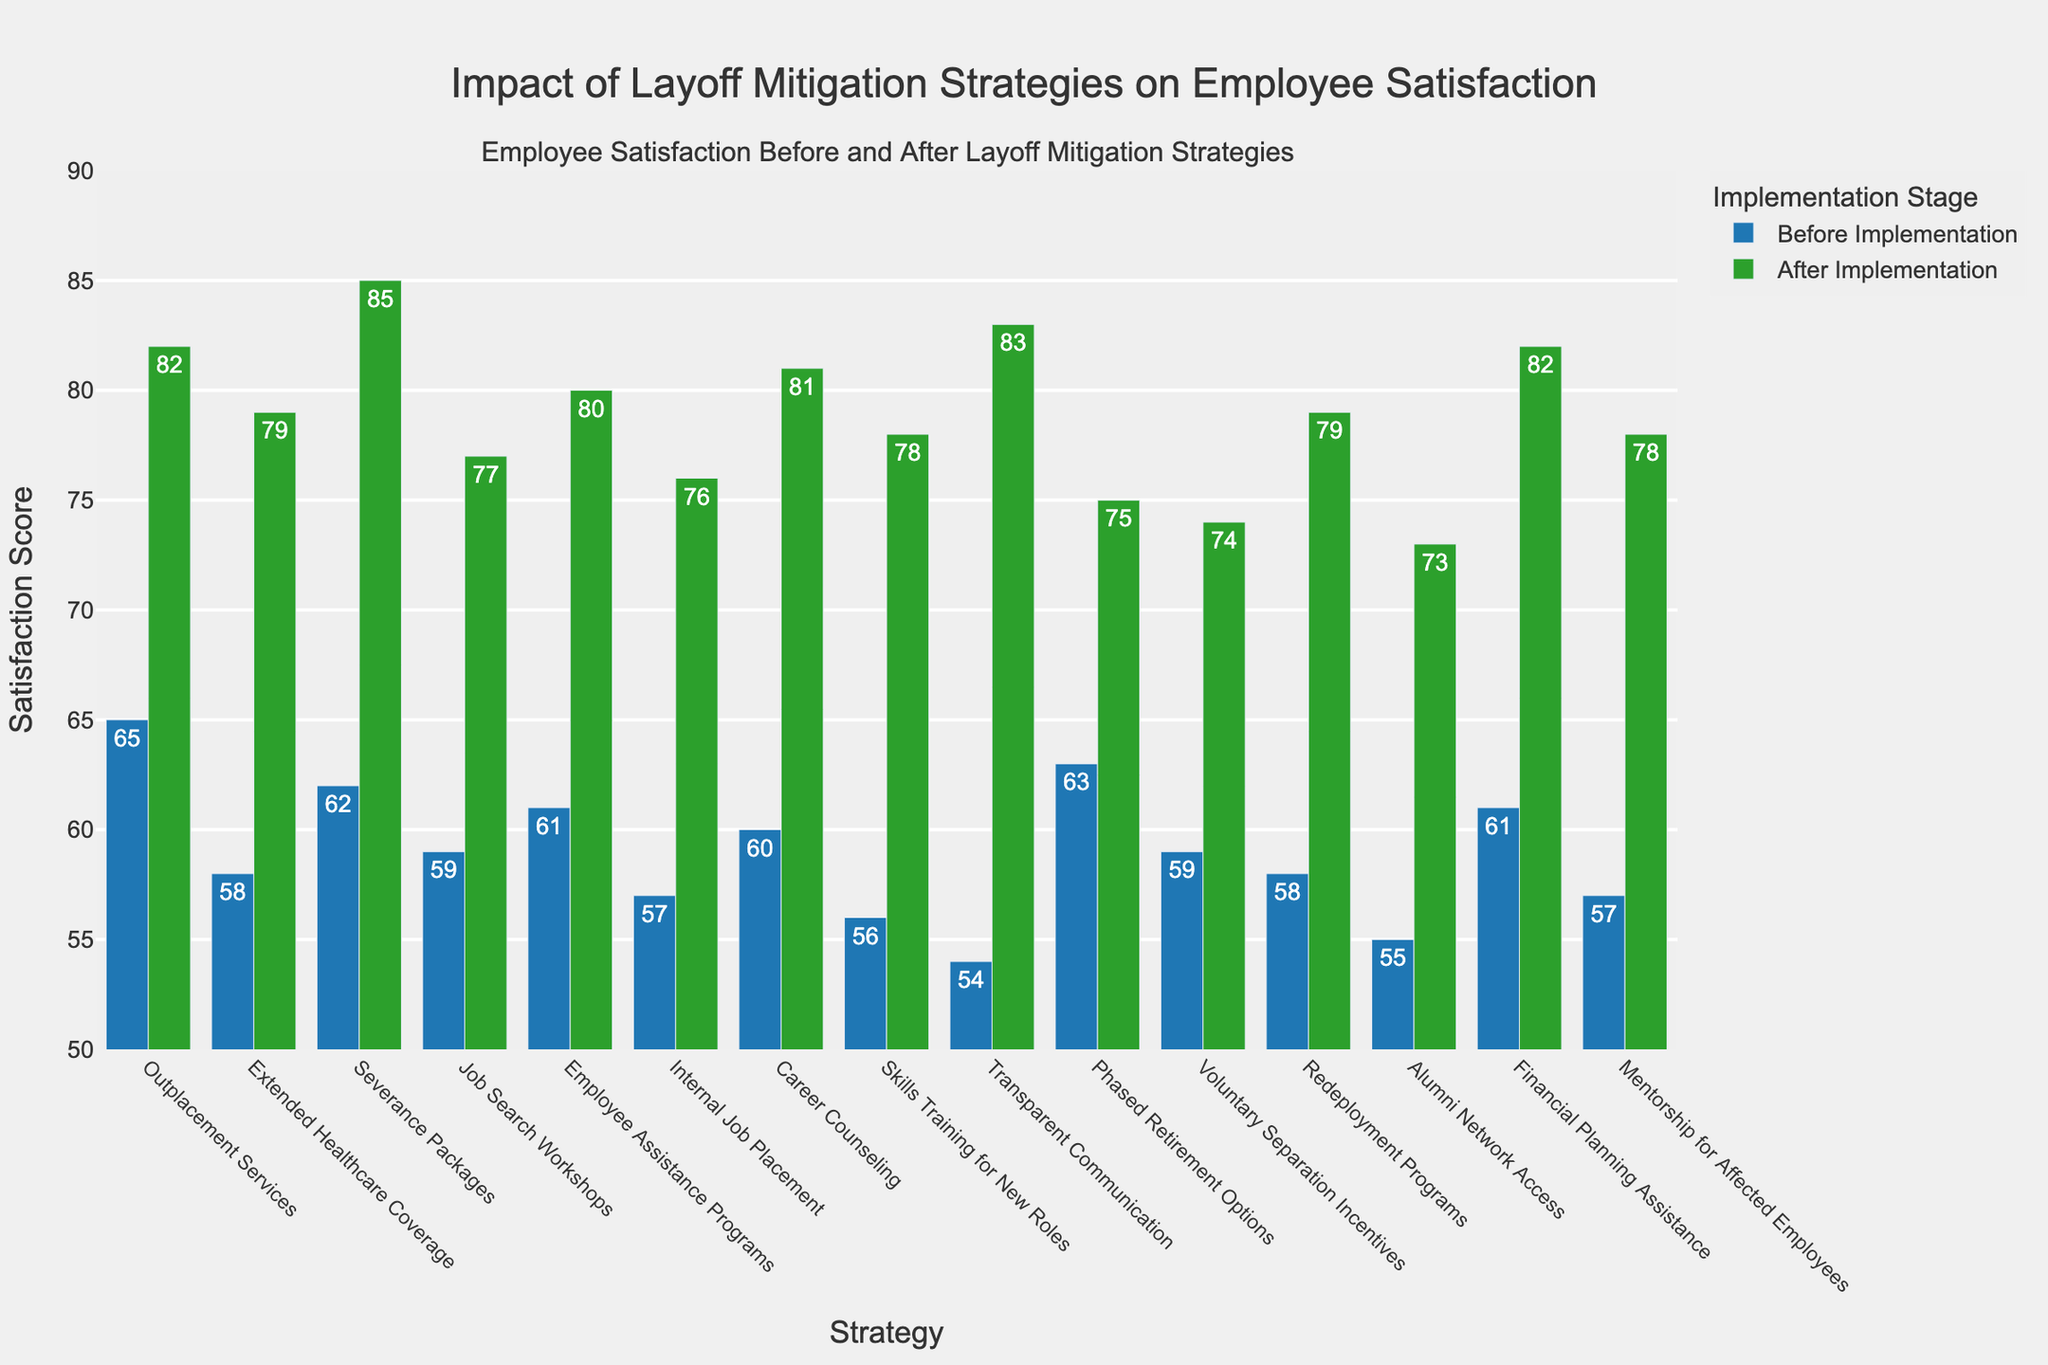Which strategy showed the greatest increase in satisfaction scores after implementation? By comparing the "Before Implementation" and "After Implementation" scores for each strategy, we find the differences. The strategy with the largest difference represents the greatest increase.
Answer: Severance Packages Which strategy had the lowest satisfaction score before implementation? By examining the bars labeled "Before Implementation," we see that the lowest score corresponds to the shortest bar.
Answer: Transparent Communication How many strategies had a satisfaction score of 80 or higher after the implementation? Count the number of bars labeled "After Implementation" that reach or exceed the value of 80 on the y-axis.
Answer: Six What is the average satisfaction score after implementing all strategies? Sum up all "After Implementation" scores and divide by the total number of strategies. Calculation: (82 + 79 + 85 + 77 + 80 + 76 + 81 + 78 + 83 + 75 + 74 + 79 + 73 + 82 + 78) / 15 = 79.2
Answer: 79.2 Which strategy had a higher satisfaction score before implementation compared to the "Extended Healthcare Coverage" strategy? Compare each "Before Implementation" score to 58, the score for "Extended Healthcare Coverage." Any score higher than 58 fits the criteria.
Answer: Outplacement Services, Severance Packages, Employee Assistance Programs, Career Counseling, Phased Retirement Options, Financial Planning Assistance What was the difference in satisfaction scores for "Job Search Workshops" before and after implementation? Subtract the "Before Implementation" score from the "After Implementation" score for the "Job Search Workshops" strategy. Calculation: 77 - 59 = 18
Answer: 18 Which strategy had the smallest improvement in satisfaction score after implementation? Calculate the difference between "Before Implementation" and "After Implementation" for each strategy and identify the smallest difference.
Answer: Phased Retirement Options How many strategies had a satisfaction score below 60 before implementation? Count the number of bars labeled "Before Implementation" that are below the value of 60 on the y-axis.
Answer: Six What is the median value of satisfaction scores after implementation? Organize the "After Implementation" scores in ascending order and identify the middle value. Sorted: [73, 74, 75, 76, 77, 78, 78, 79, 79, 80, 81, 82, 82, 83, 85]. Middle value: 79
Answer: 79 Do any strategies have an equal satisfaction score before and after implementation? By visually inspecting the heights of the corresponding bars, confirm whether any pairs are equal.
Answer: No 